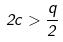Convert formula to latex. <formula><loc_0><loc_0><loc_500><loc_500>2 c > \frac { q } { 2 }</formula> 